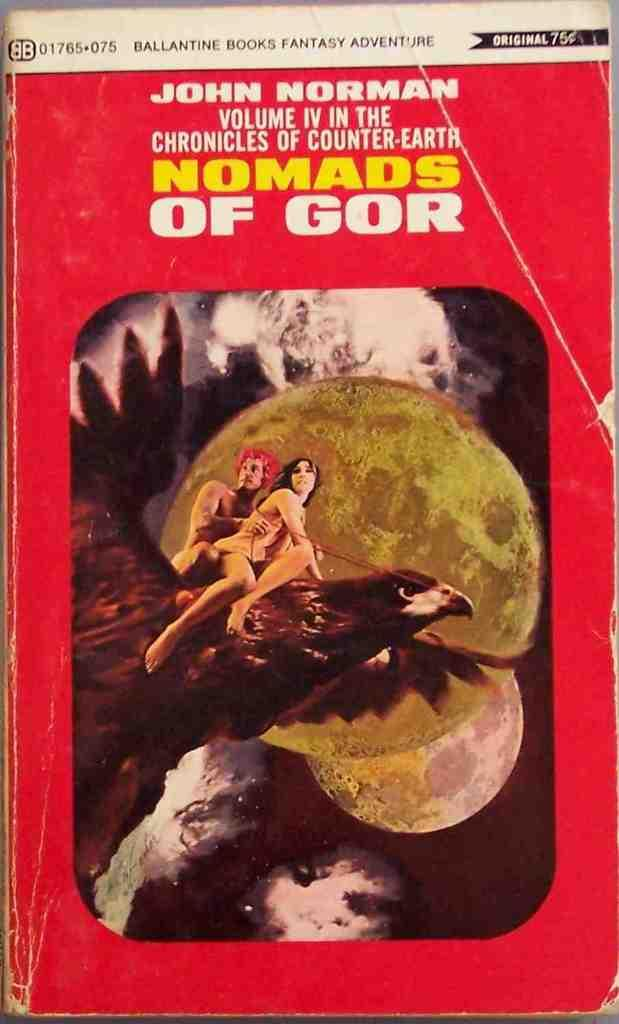<image>
Summarize the visual content of the image. The book Nomads of Gor has two people riding a bird on the cover. 